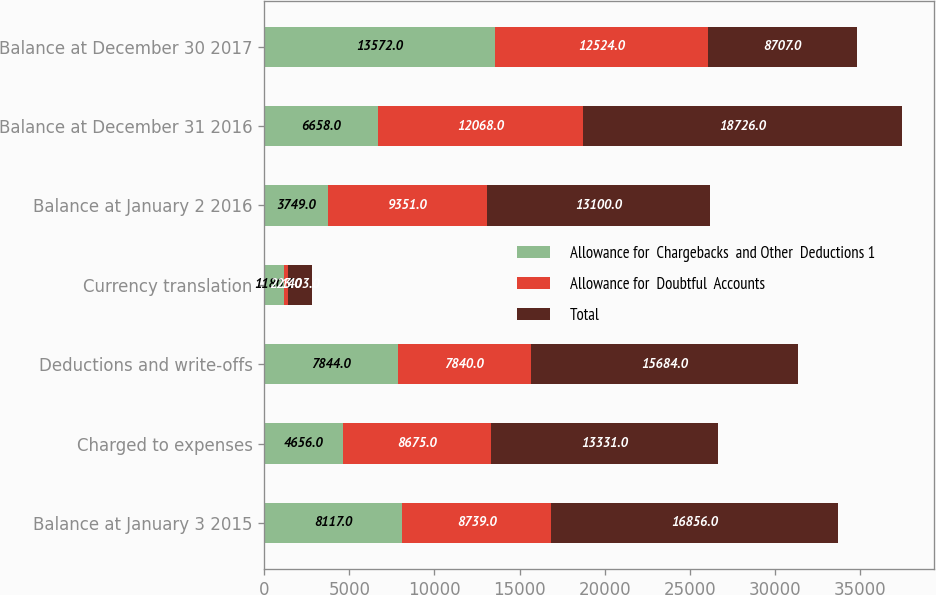<chart> <loc_0><loc_0><loc_500><loc_500><stacked_bar_chart><ecel><fcel>Balance at January 3 2015<fcel>Charged to expenses<fcel>Deductions and write-offs<fcel>Currency translation<fcel>Balance at January 2 2016<fcel>Balance at December 31 2016<fcel>Balance at December 30 2017<nl><fcel>Allowance for  Chargebacks  and Other  Deductions 1<fcel>8117<fcel>4656<fcel>7844<fcel>1180<fcel>3749<fcel>6658<fcel>13572<nl><fcel>Allowance for  Doubtful  Accounts<fcel>8739<fcel>8675<fcel>7840<fcel>223<fcel>9351<fcel>12068<fcel>12524<nl><fcel>Total<fcel>16856<fcel>13331<fcel>15684<fcel>1403<fcel>13100<fcel>18726<fcel>8707<nl></chart> 